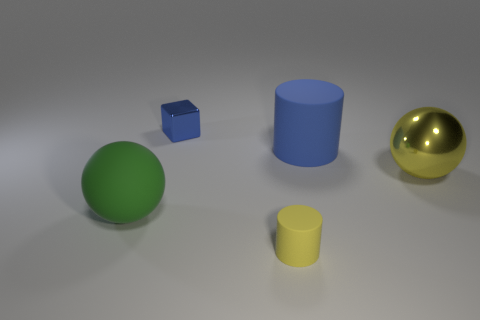Add 4 big matte cylinders. How many objects exist? 9 Subtract all cubes. How many objects are left? 4 Subtract all big yellow shiny spheres. Subtract all big blue cylinders. How many objects are left? 3 Add 2 tiny yellow rubber cylinders. How many tiny yellow rubber cylinders are left? 3 Add 3 large rubber objects. How many large rubber objects exist? 5 Subtract 0 red cylinders. How many objects are left? 5 